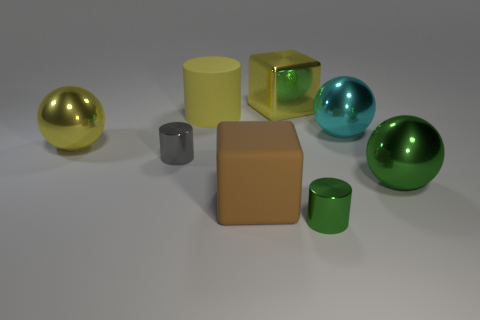Subtract all small cylinders. How many cylinders are left? 1 Add 2 large yellow shiny balls. How many objects exist? 10 Subtract all yellow blocks. How many blocks are left? 1 Subtract 3 balls. How many balls are left? 0 Subtract all cyan cylinders. Subtract all gray spheres. How many cylinders are left? 3 Subtract all cubes. How many objects are left? 6 Subtract all tiny blue metal cubes. Subtract all large yellow matte things. How many objects are left? 7 Add 1 large things. How many large things are left? 7 Add 2 brown matte things. How many brown matte things exist? 3 Subtract 1 gray cylinders. How many objects are left? 7 